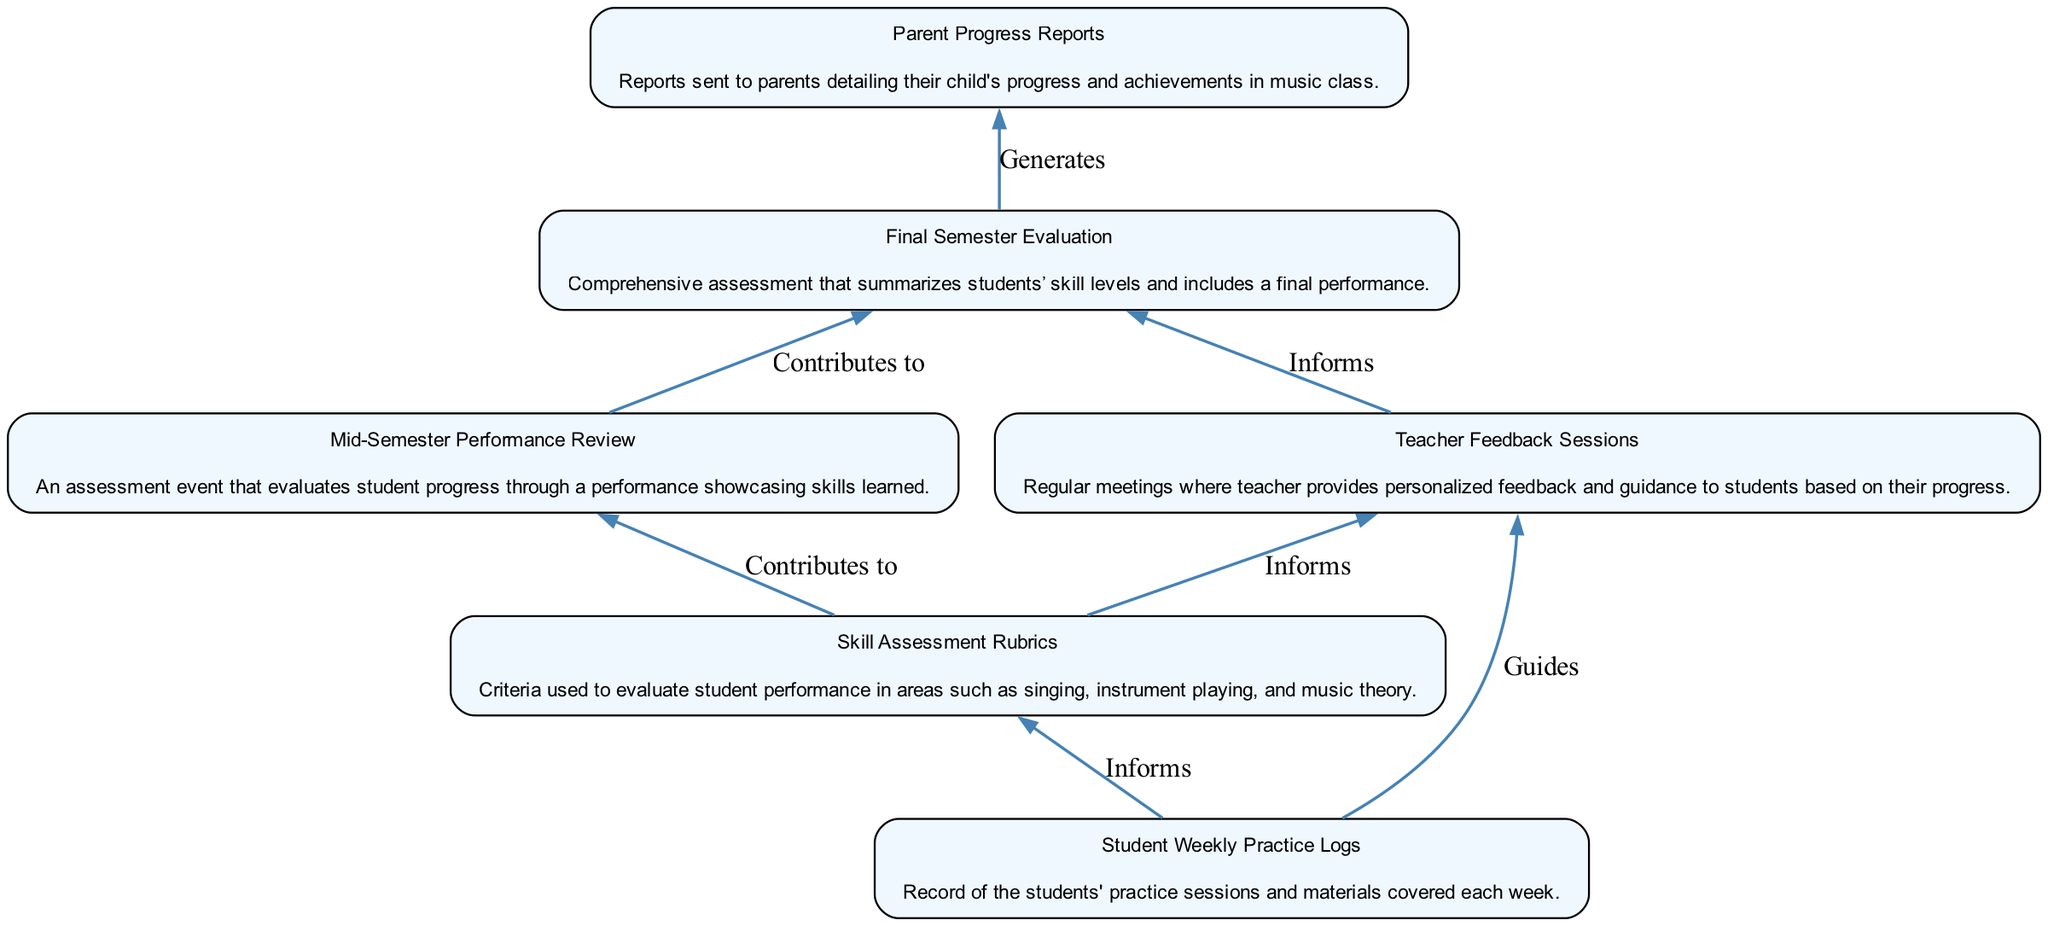What is the first node in the diagram? The first node in the diagram is "Student Weekly Practice Logs". This is identified as the starting point of the flow chart, which represents the initial collection of information.
Answer: Student Weekly Practice Logs How many nodes are in the diagram? The total number of nodes in the diagram is six. Each element listed contributes a node, and there are six elements in the provided data.
Answer: Six What relationship contributes to the "Mid-Semester Performance Review"? The "Mid-Semester Performance Review" is contributed to by the "Skill Assessment Rubrics". This connection shows that the assessment is based on the evaluation criteria defined in the rubrics.
Answer: Skill Assessment Rubrics Which node generates parent reports? The node that generates parent reports is the "Final Semester Evaluation". This indicates that the final evaluation summarizes student progress and achievements, which are then communicated to parents.
Answer: Final Semester Evaluation What role do "Teacher Feedback Sessions" play in the diagram? "Teacher Feedback Sessions" inform the "Final Semester Evaluation". This means that feedback given during these sessions is essential for the final assessment of students' skills at the end of the term.
Answer: Informs What is the relationship between "Student Weekly Practice Logs" and "Teacher Feedback Sessions"? The relationship between "Student Weekly Practice Logs" and "Teacher Feedback Sessions" is that the logs guide the feedback sessions. This suggests that teachers use the practice logs to understand student progress and provide targeted feedback.
Answer: Guides Which two nodes are directly connected to the "Final Semester Evaluation"? The two nodes directly connected to the "Final Semester Evaluation" are "Mid-Semester Performance Review" and "Teacher Feedback Sessions". Both contribute information necessary for the final evaluation output.
Answer: Mid-Semester Performance Review and Teacher Feedback Sessions How do "Student Weekly Practice Logs" and "Skill Assessment Rubrics" relate to "Teacher Feedback Sessions"? "Student Weekly Practice Logs" inform "Teacher Feedback Sessions", and "Skill Assessment Rubrics" also inform them. This implies both practice records and assessment criteria are utilized for providing feedback during these sessions.
Answer: Inform What does the "Mid-Semester Performance Review" lead to in the diagram? The "Mid-Semester Performance Review" leads to the "Final Semester Evaluation". This connection indicates that insights gathered from the mid-semester review contribute significantly to the final assessment.
Answer: Final Semester Evaluation 